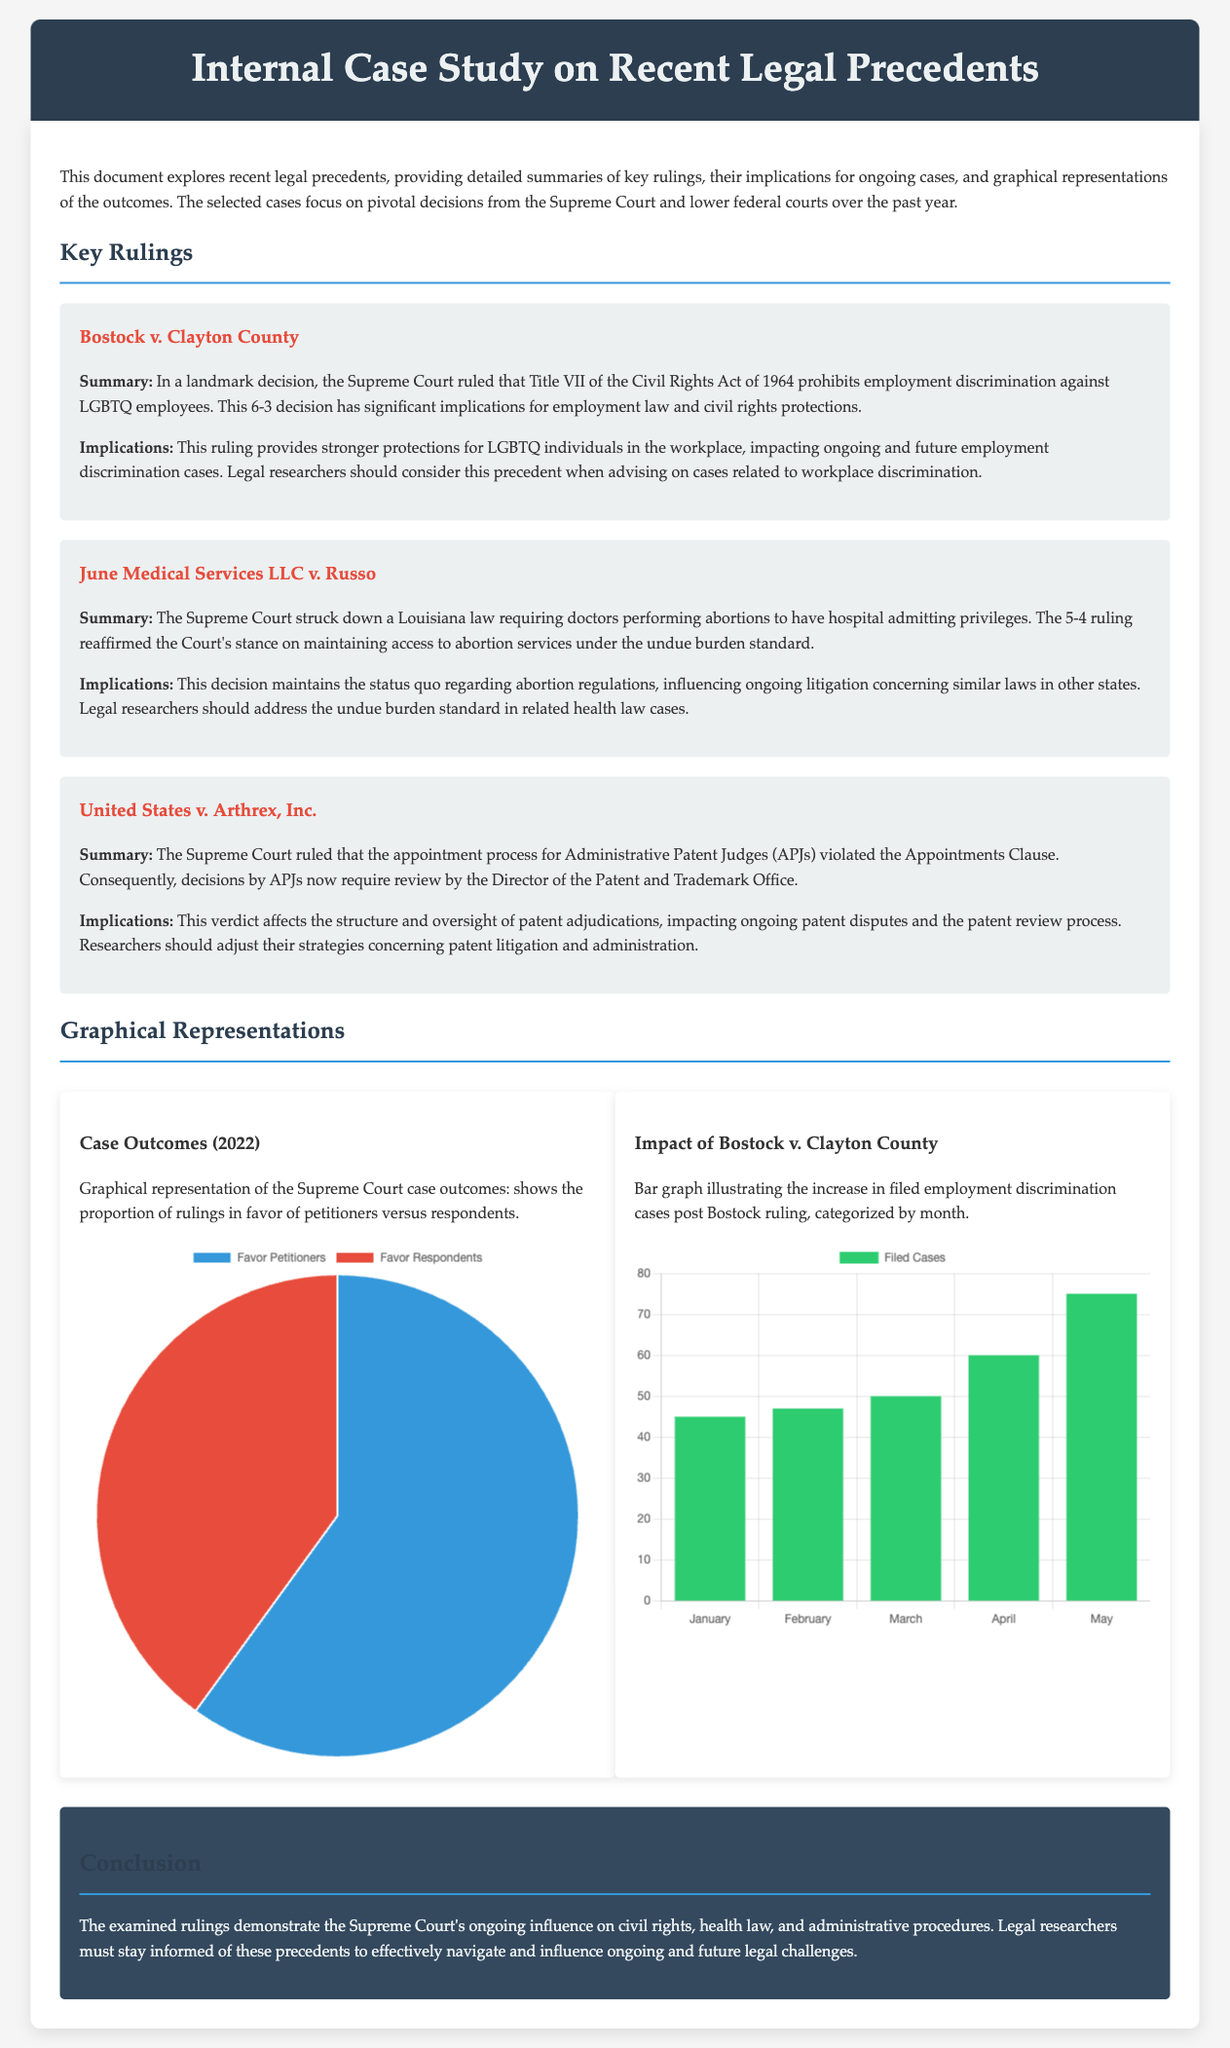What is the title of the study? The title is presented at the top of the document in the header section.
Answer: Internal Case Study on Recent Legal Precedents How many cases are summarized in the document? The number of cases is indicated within the content section where summaries are provided.
Answer: Three What was the outcome of Bostock v. Clayton County? The outcome is summarized in the case section that discusses the Supreme Court's ruling.
Answer: Prohibits employment discrimination against LGBTQ employees Which court made the ruling in United States v. Arthrex, Inc.? The court that made the ruling is mentioned in the context of the case.
Answer: Supreme Court What is the response percentage favoring petitioners in the case outcomes pie chart? This percentage is shown in the graphical representation of case outcomes.
Answer: 60 What does the bar graph represent in the study? The bar graph's purpose is mentioned in the section describing the graphs.
Answer: Increase in filed employment discrimination cases What legal standard was reaffirmed in June Medical Services LLC v. Russo? The standard is referenced in the implications provided for the case ruling.
Answer: Undue burden standard How many filed cases occurred in May according to the Bostock impact graph? The specific number for May is provided in the bar chart data.
Answer: 75 Which color represents cases favoring respondents in the case outcomes chart? The pie chart's color assignments are described, indicating specific colors for each category.
Answer: Red 